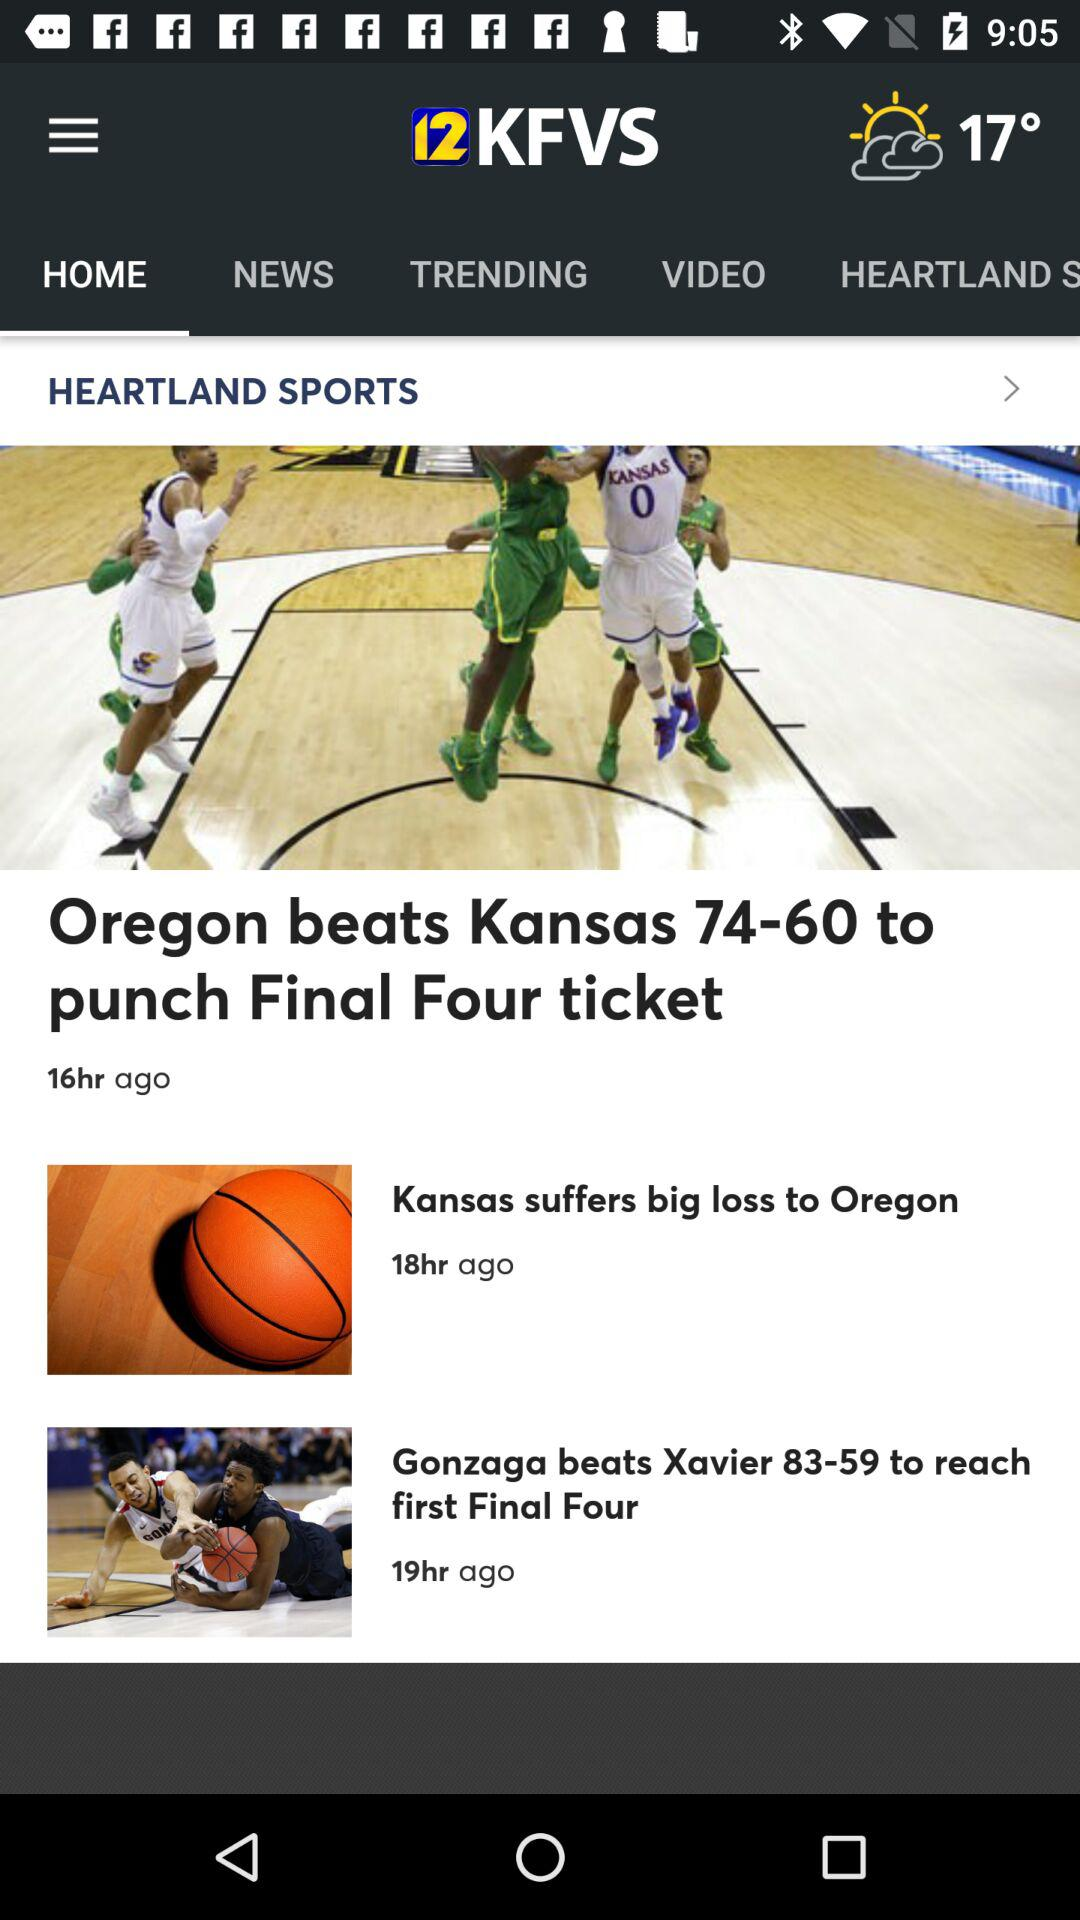How many more hours ago was the Kansas game played than the Gonzaga game?
Answer the question using a single word or phrase. 1 